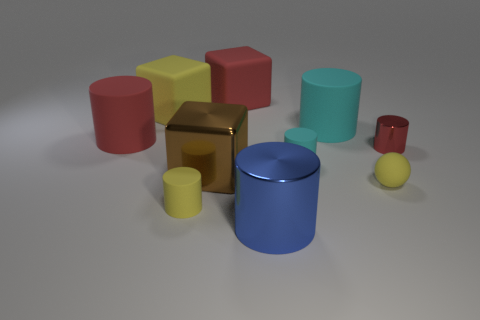There is a red rubber thing to the right of the large red matte cylinder; is it the same shape as the tiny shiny thing? no 